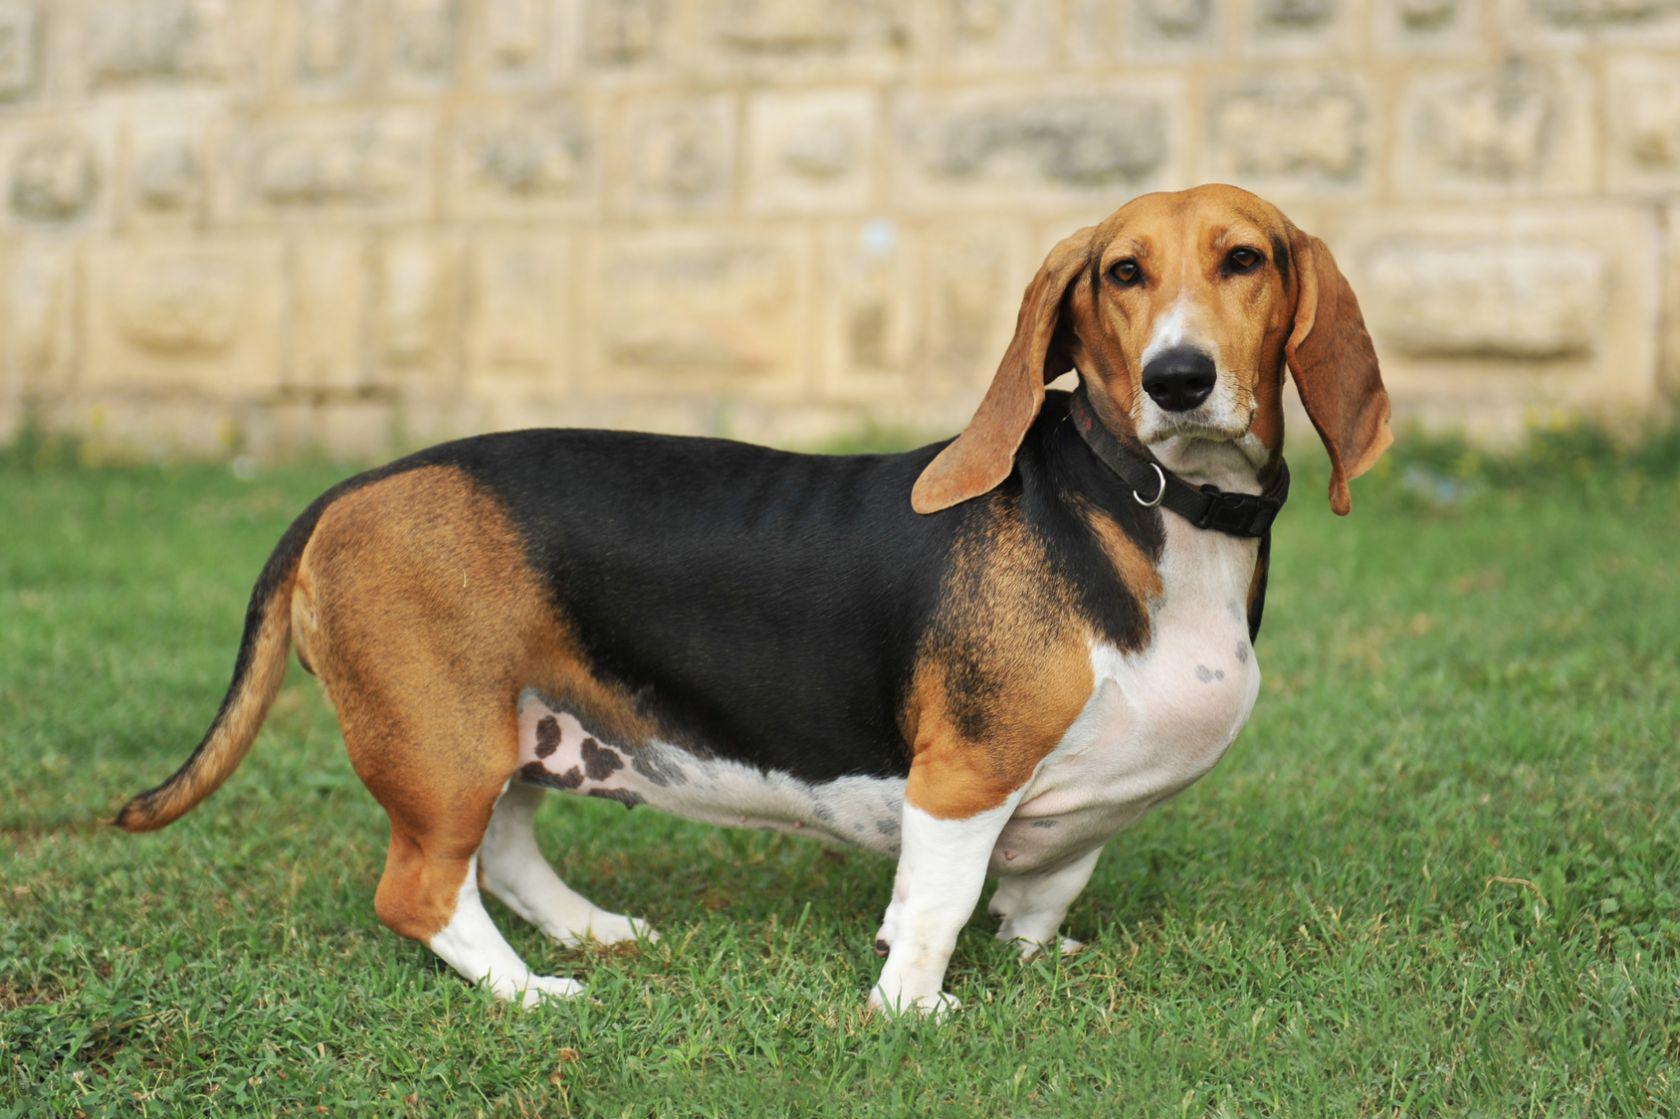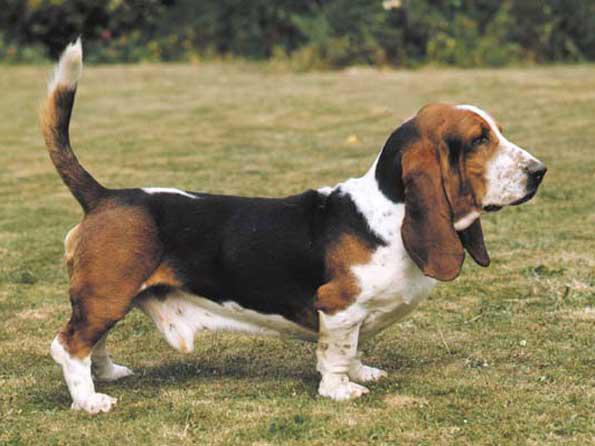The first image is the image on the left, the second image is the image on the right. For the images shown, is this caption "In one image there is a lone basset hound standing outside facing the left side of the image." true? Answer yes or no. No. The first image is the image on the left, the second image is the image on the right. Examine the images to the left and right. Is the description "One dog is standing by itself with its tail up in the air." accurate? Answer yes or no. Yes. 